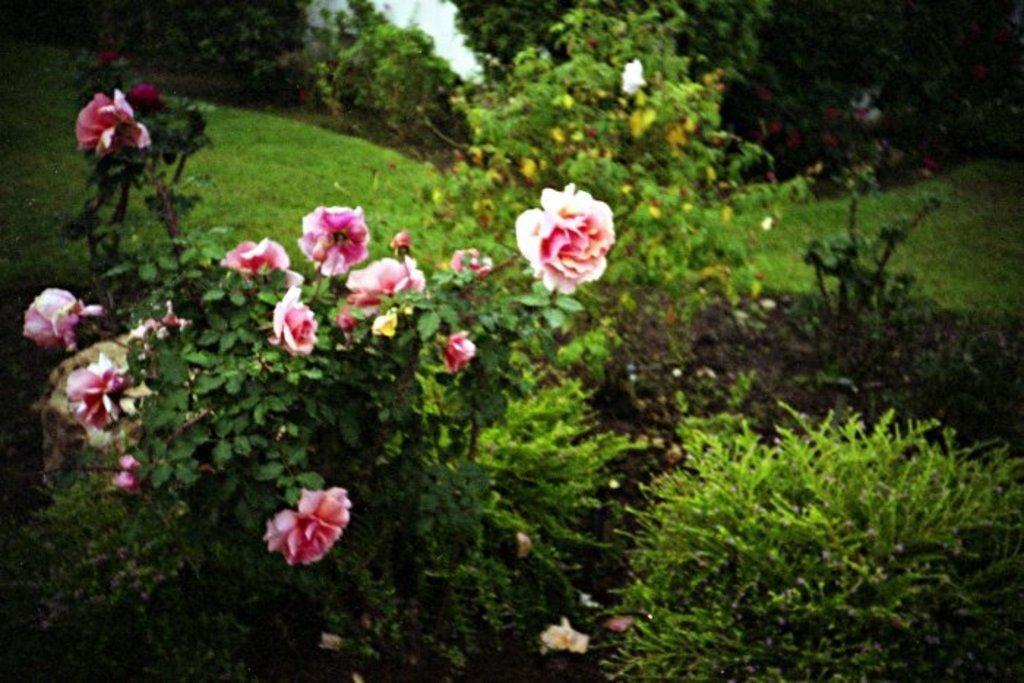What types of living organisms can be seen in the image? There are different types of plants in the image. Are there any specific features of the plants that can be observed? Yes, there are flowers in the image. What can be seen in the background of the image? There are plants and grass in the background of the image. How much fuel is required to power the plants in the image? Plants do not require fuel to grow or function, so this question is not applicable to the image. 